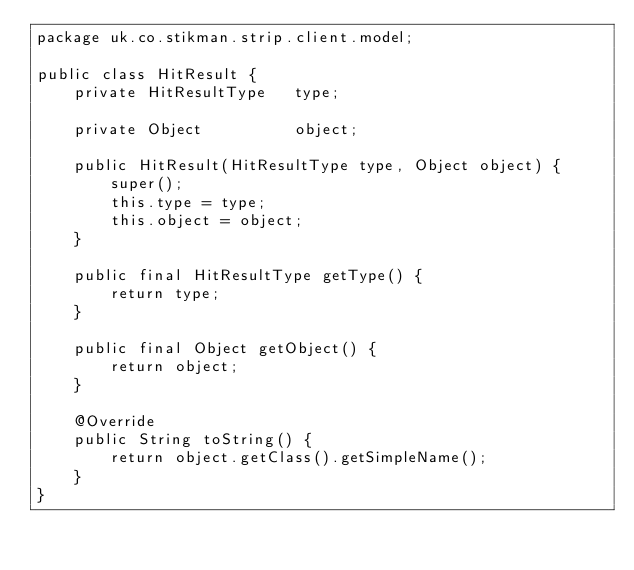Convert code to text. <code><loc_0><loc_0><loc_500><loc_500><_Java_>package uk.co.stikman.strip.client.model;

public class HitResult {
	private HitResultType	type;

	private Object			object;

	public HitResult(HitResultType type, Object object) {
		super();
		this.type = type;
		this.object = object;
	}

	public final HitResultType getType() {
		return type;
	}

	public final Object getObject() {
		return object;
	}

	@Override
	public String toString() {
		return object.getClass().getSimpleName();
	}
}
</code> 